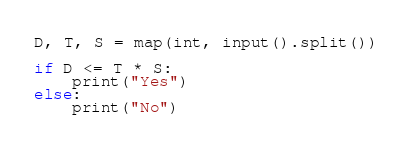Convert code to text. <code><loc_0><loc_0><loc_500><loc_500><_Python_>D, T, S = map(int, input().split())

if D <= T * S:
    print("Yes")
else:
    print("No")
</code> 